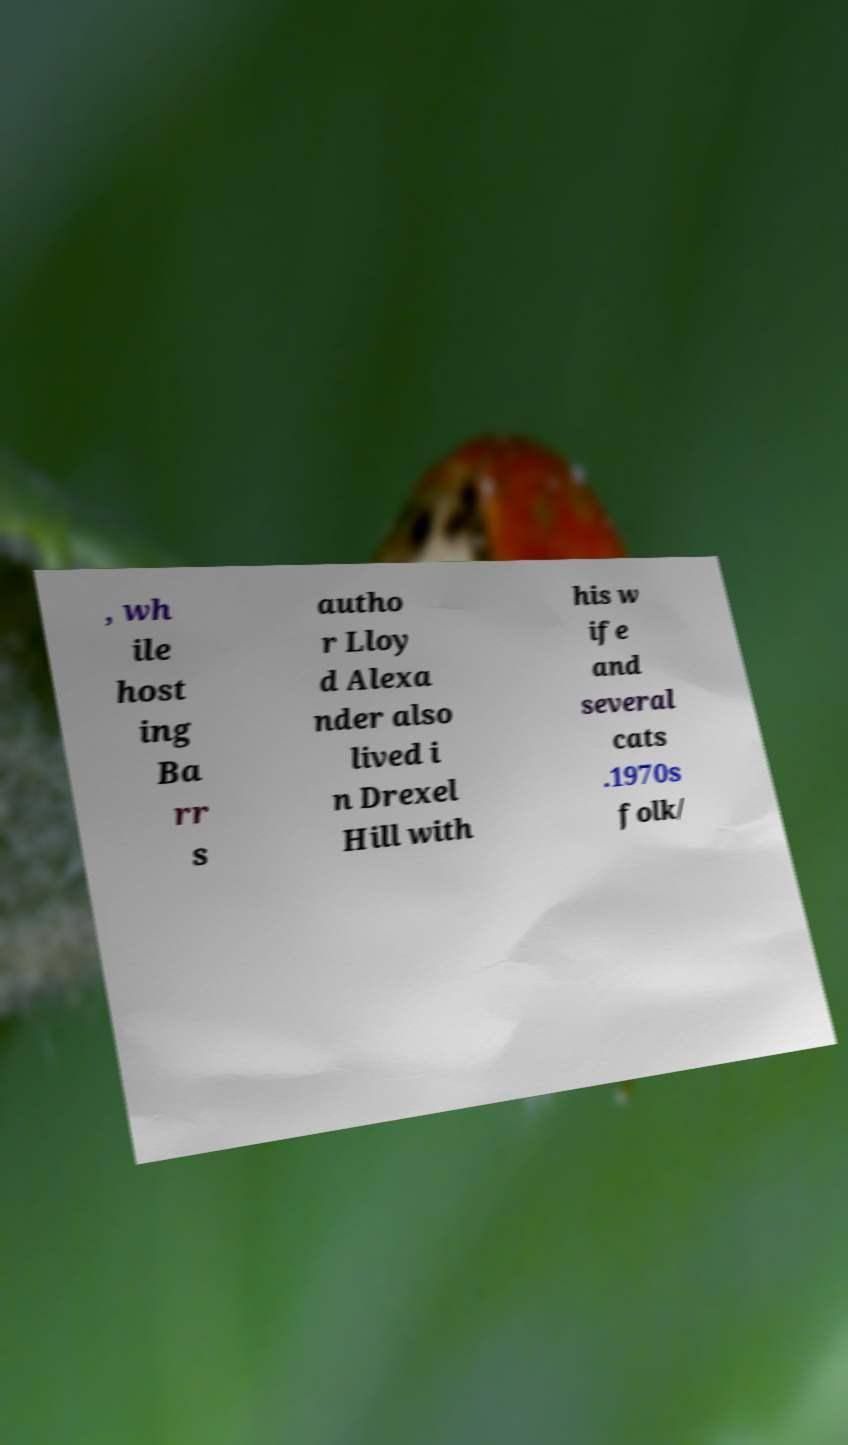Could you extract and type out the text from this image? , wh ile host ing Ba rr s autho r Lloy d Alexa nder also lived i n Drexel Hill with his w ife and several cats .1970s folk/ 